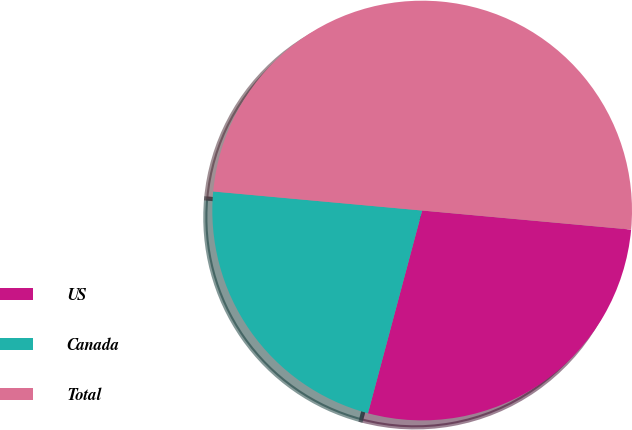Convert chart to OTSL. <chart><loc_0><loc_0><loc_500><loc_500><pie_chart><fcel>US<fcel>Canada<fcel>Total<nl><fcel>27.71%<fcel>22.29%<fcel>50.0%<nl></chart> 